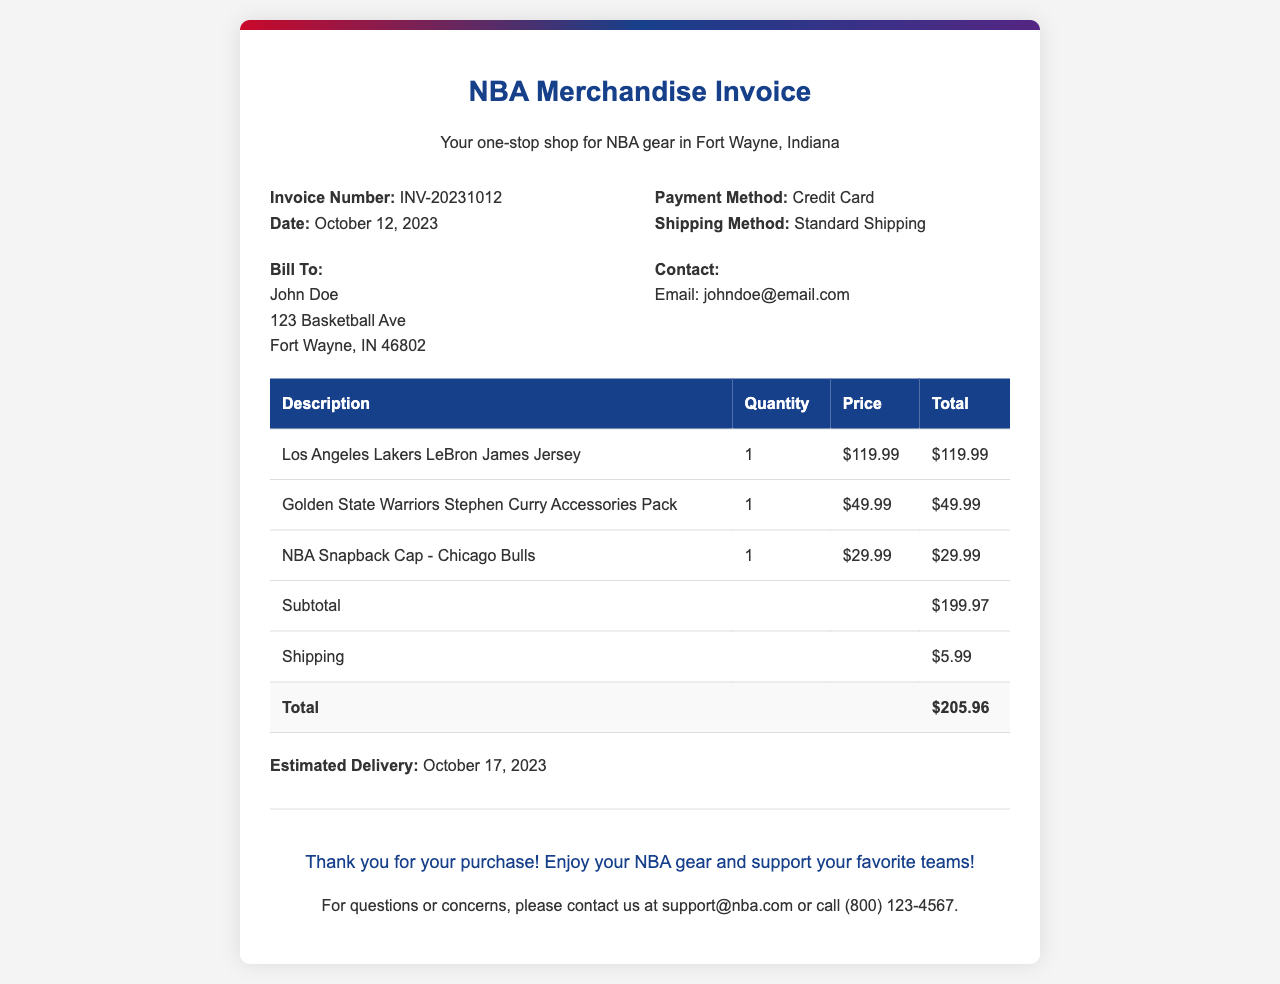What is the invoice number? The invoice number is a unique identifier for the transaction, which is stated in the document.
Answer: INV-20231012 What is the date of the invoice? The date of the invoice is mentioned in the document, indicating when the transaction took place.
Answer: October 12, 2023 What is the total amount due? The total amount is the final calculated figure that includes all items and shipping, listed at the end of the invoice section.
Answer: $205.96 What is the estimated delivery date? The estimated delivery date is provided in the document to inform the customer when they can expect their items.
Answer: October 17, 2023 What jersey was purchased? The document lists specific items purchased, including merchandise related to specific players and teams.
Answer: Los Angeles Lakers LeBron James Jersey What shipping method was used? The shipping method indicates how the items are delivered to the customer and is specified in the document.
Answer: Standard Shipping How much was charged for shipping? The shipping charge is a separate amount added to the subtotal and is noted in the invoice.
Answer: $5.99 What payment method was used? The payment method indicates how the transaction was completed, which is mentioned in the document.
Answer: Credit Card What accessories were included in the order? The accessories purchased are listed in the invoice details, highlighting specific items bought.
Answer: Golden State Warriors Stephen Curry Accessories Pack Who is the bill to? The 'Bill To' section provides the name and address of the purchaser, which is included in the document.
Answer: John Doe, 123 Basketball Ave, Fort Wayne, IN 46802 